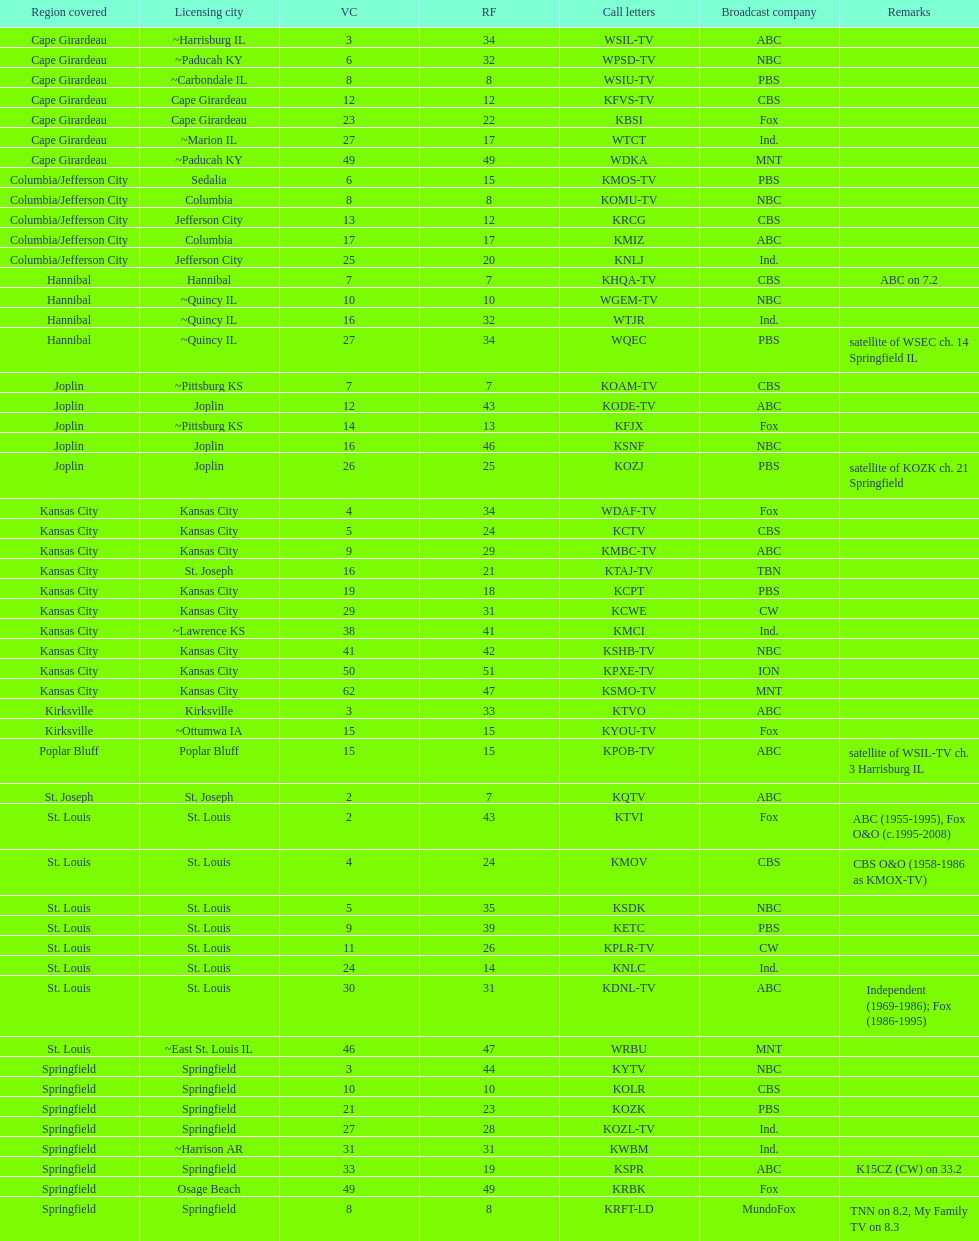How many of these missouri tv stations are actually licensed in a city in illinois (il)? 7. 